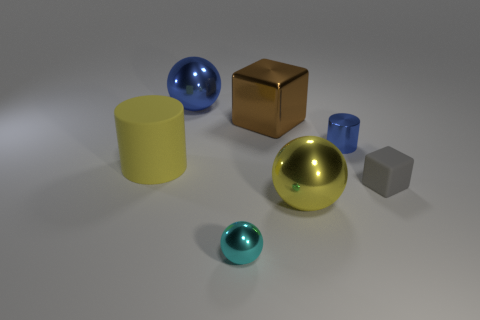Are there any other big yellow cylinders made of the same material as the yellow cylinder? Based on the image, there is only one large yellow cylinder present. Objects made of similar materials typically exhibit comparable textures and reflections. No other objects in the image share the same visual characteristics of material as the yellow cylinder. 